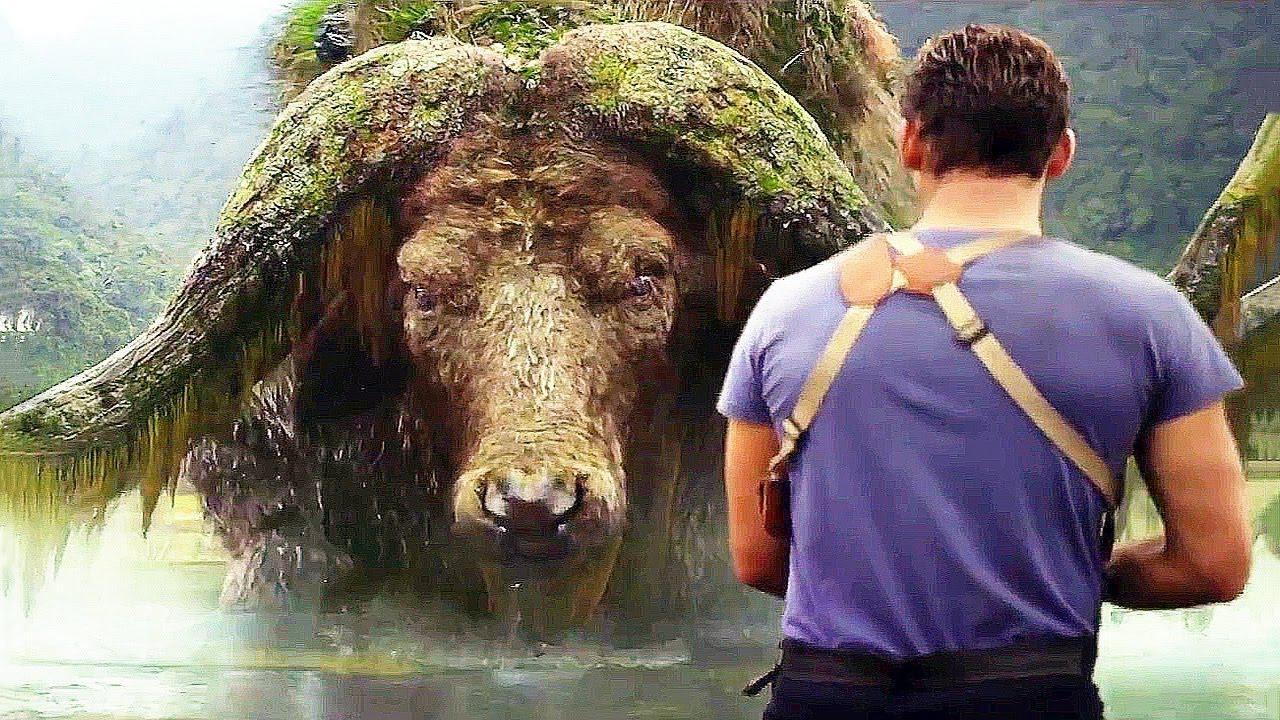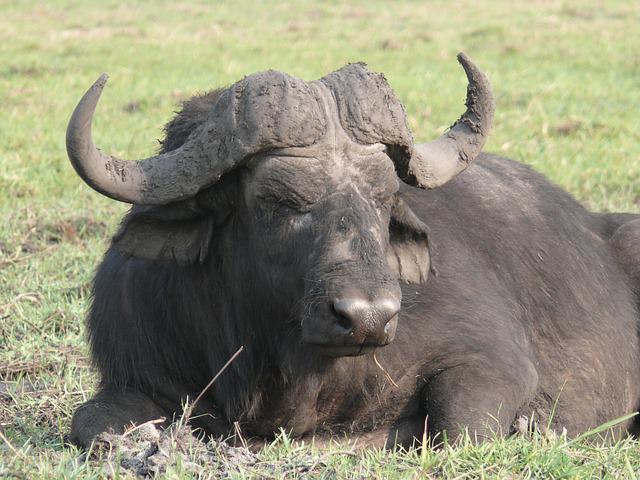The first image is the image on the left, the second image is the image on the right. For the images displayed, is the sentence "The left image shows a horned animal in water up to its chest, and the right image shows a buffalo on dry ground." factually correct? Answer yes or no. Yes. 